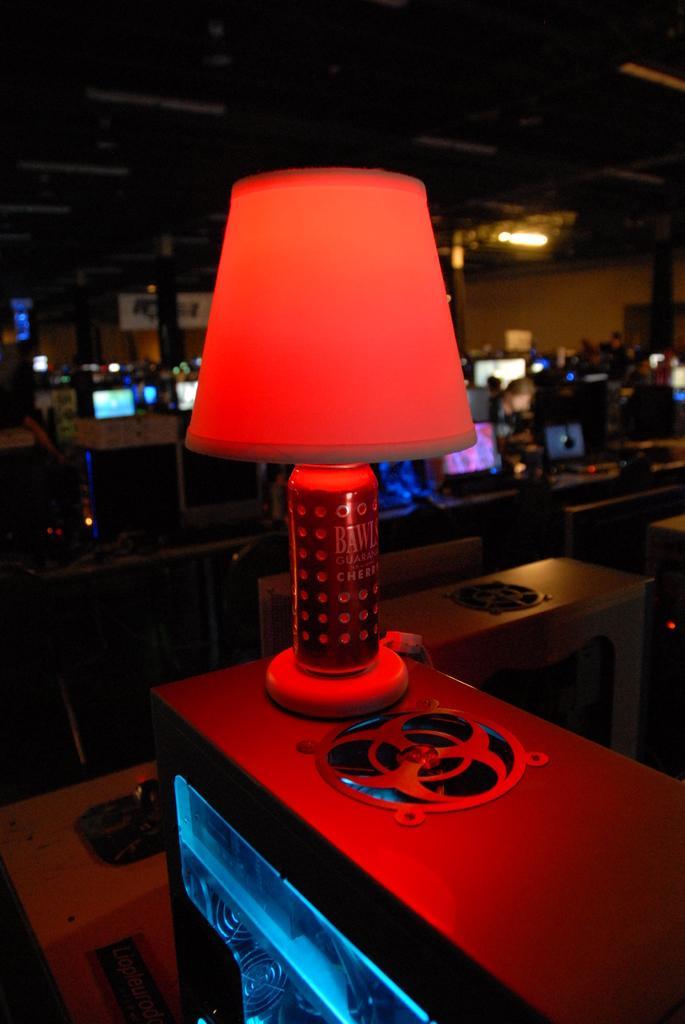Can you describe this image briefly? In this image there is a table, on that table there is a table lamp, in the background there are tables, on that tables there are computers, at the top there is a roof and a light. 